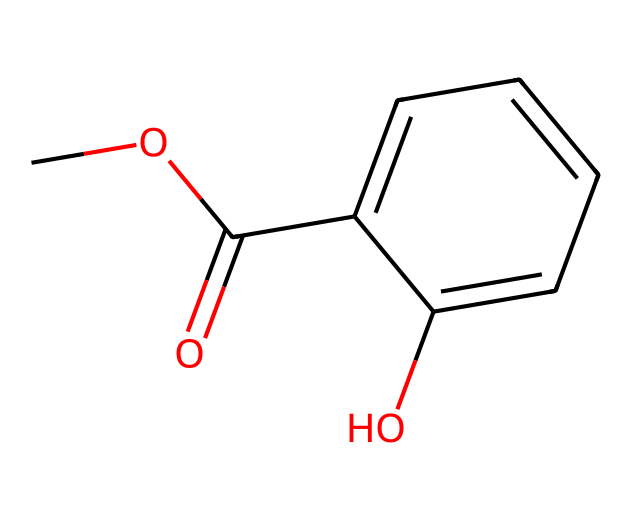How many carbon atoms are in methyl salicylate? The structure indicated by the SMILES has a total of 9 carbon atoms. This can be counted directly from the representation: there are 6 carbon atoms in the aromatic ring, 1 in the ester linkage, and 2 in the methyl group.
Answer: 9 What functional group characterizes methyl salicylate? The smile indicates the presence of a carbonyl group (C=O) and an -O- (ether) linkage. These features categorize it as an ester.
Answer: ester How many hydrogen atoms are in the structure of methyl salicylate? To find the number of hydrogen atoms, we can analyze each carbon's valency (4) and the implied hydrogens based on how many bonds each carbon has. Upon summing them up from the structure, we find there are 10 hydrogen atoms in total.
Answer: 10 What is the molecular formula of methyl salicylate? By counting the atoms represented in the SMILES, we have 9 carbons (C), 10 hydrogens (H), and 3 oxygens (O). Combining these gives the molecular formula C9H10O3.
Answer: C9H10O3 Which part of methyl salicylate is responsible for its pain-relief properties? The ester functional group along with the aromatic ring contributes to the compound's ability to provide relief, specifically through its derived mechanism of action recognized in medicinal chemistry.
Answer: ester functional group How many rings are present in the structure of methyl salicylate? Observing the structure, there is one aromatic ring within the molecular structure visible in the SMILES code, which signifies a cyclical arrangement of carbon atoms.
Answer: 1 